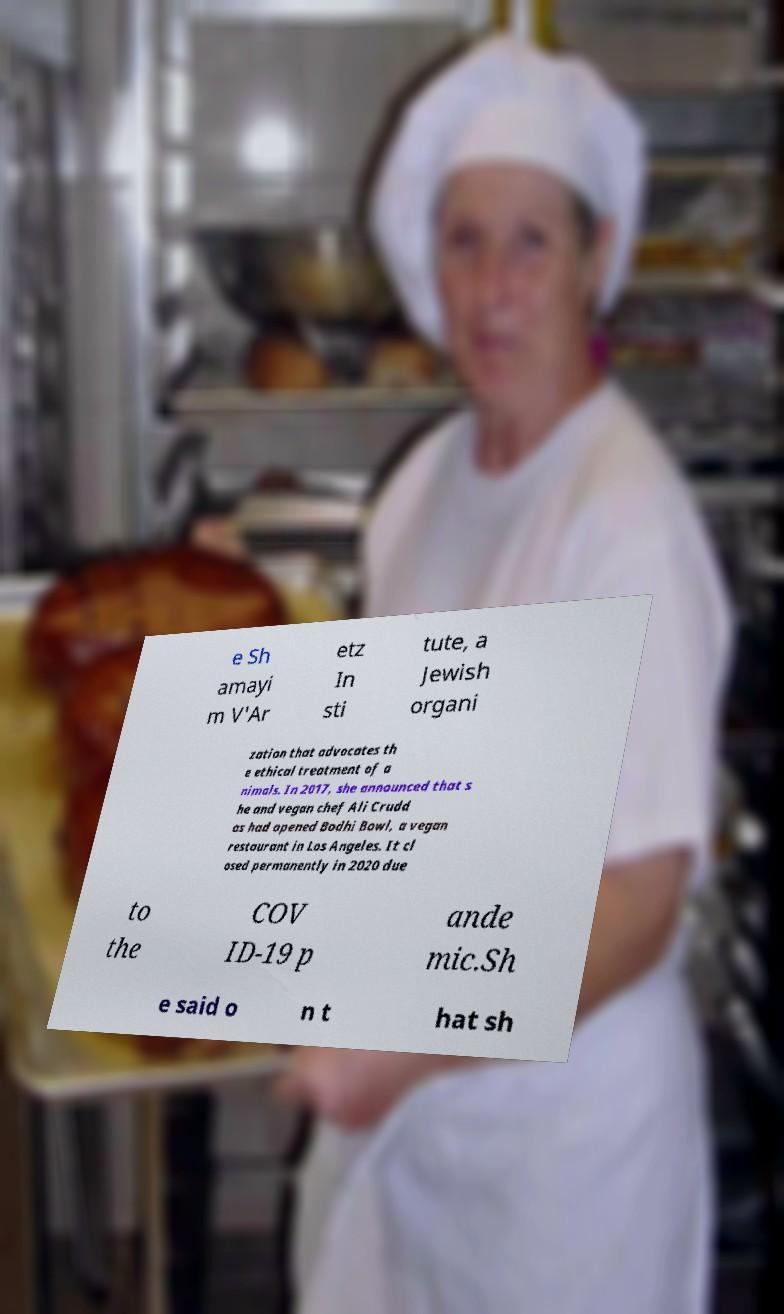For documentation purposes, I need the text within this image transcribed. Could you provide that? e Sh amayi m V'Ar etz In sti tute, a Jewish organi zation that advocates th e ethical treatment of a nimals. In 2017, she announced that s he and vegan chef Ali Crudd as had opened Bodhi Bowl, a vegan restaurant in Los Angeles. It cl osed permanently in 2020 due to the COV ID-19 p ande mic.Sh e said o n t hat sh 